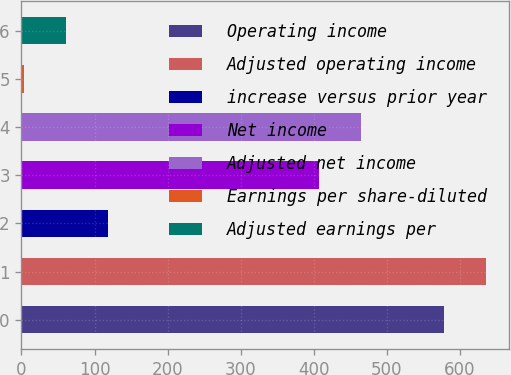Convert chart. <chart><loc_0><loc_0><loc_500><loc_500><bar_chart><fcel>Operating income<fcel>Adjusted operating income<fcel>increase versus prior year<fcel>Net income<fcel>Adjusted net income<fcel>Earnings per share-diluted<fcel>Adjusted earnings per<nl><fcel>578.3<fcel>635.83<fcel>118.1<fcel>407.8<fcel>465.33<fcel>3.04<fcel>60.57<nl></chart> 